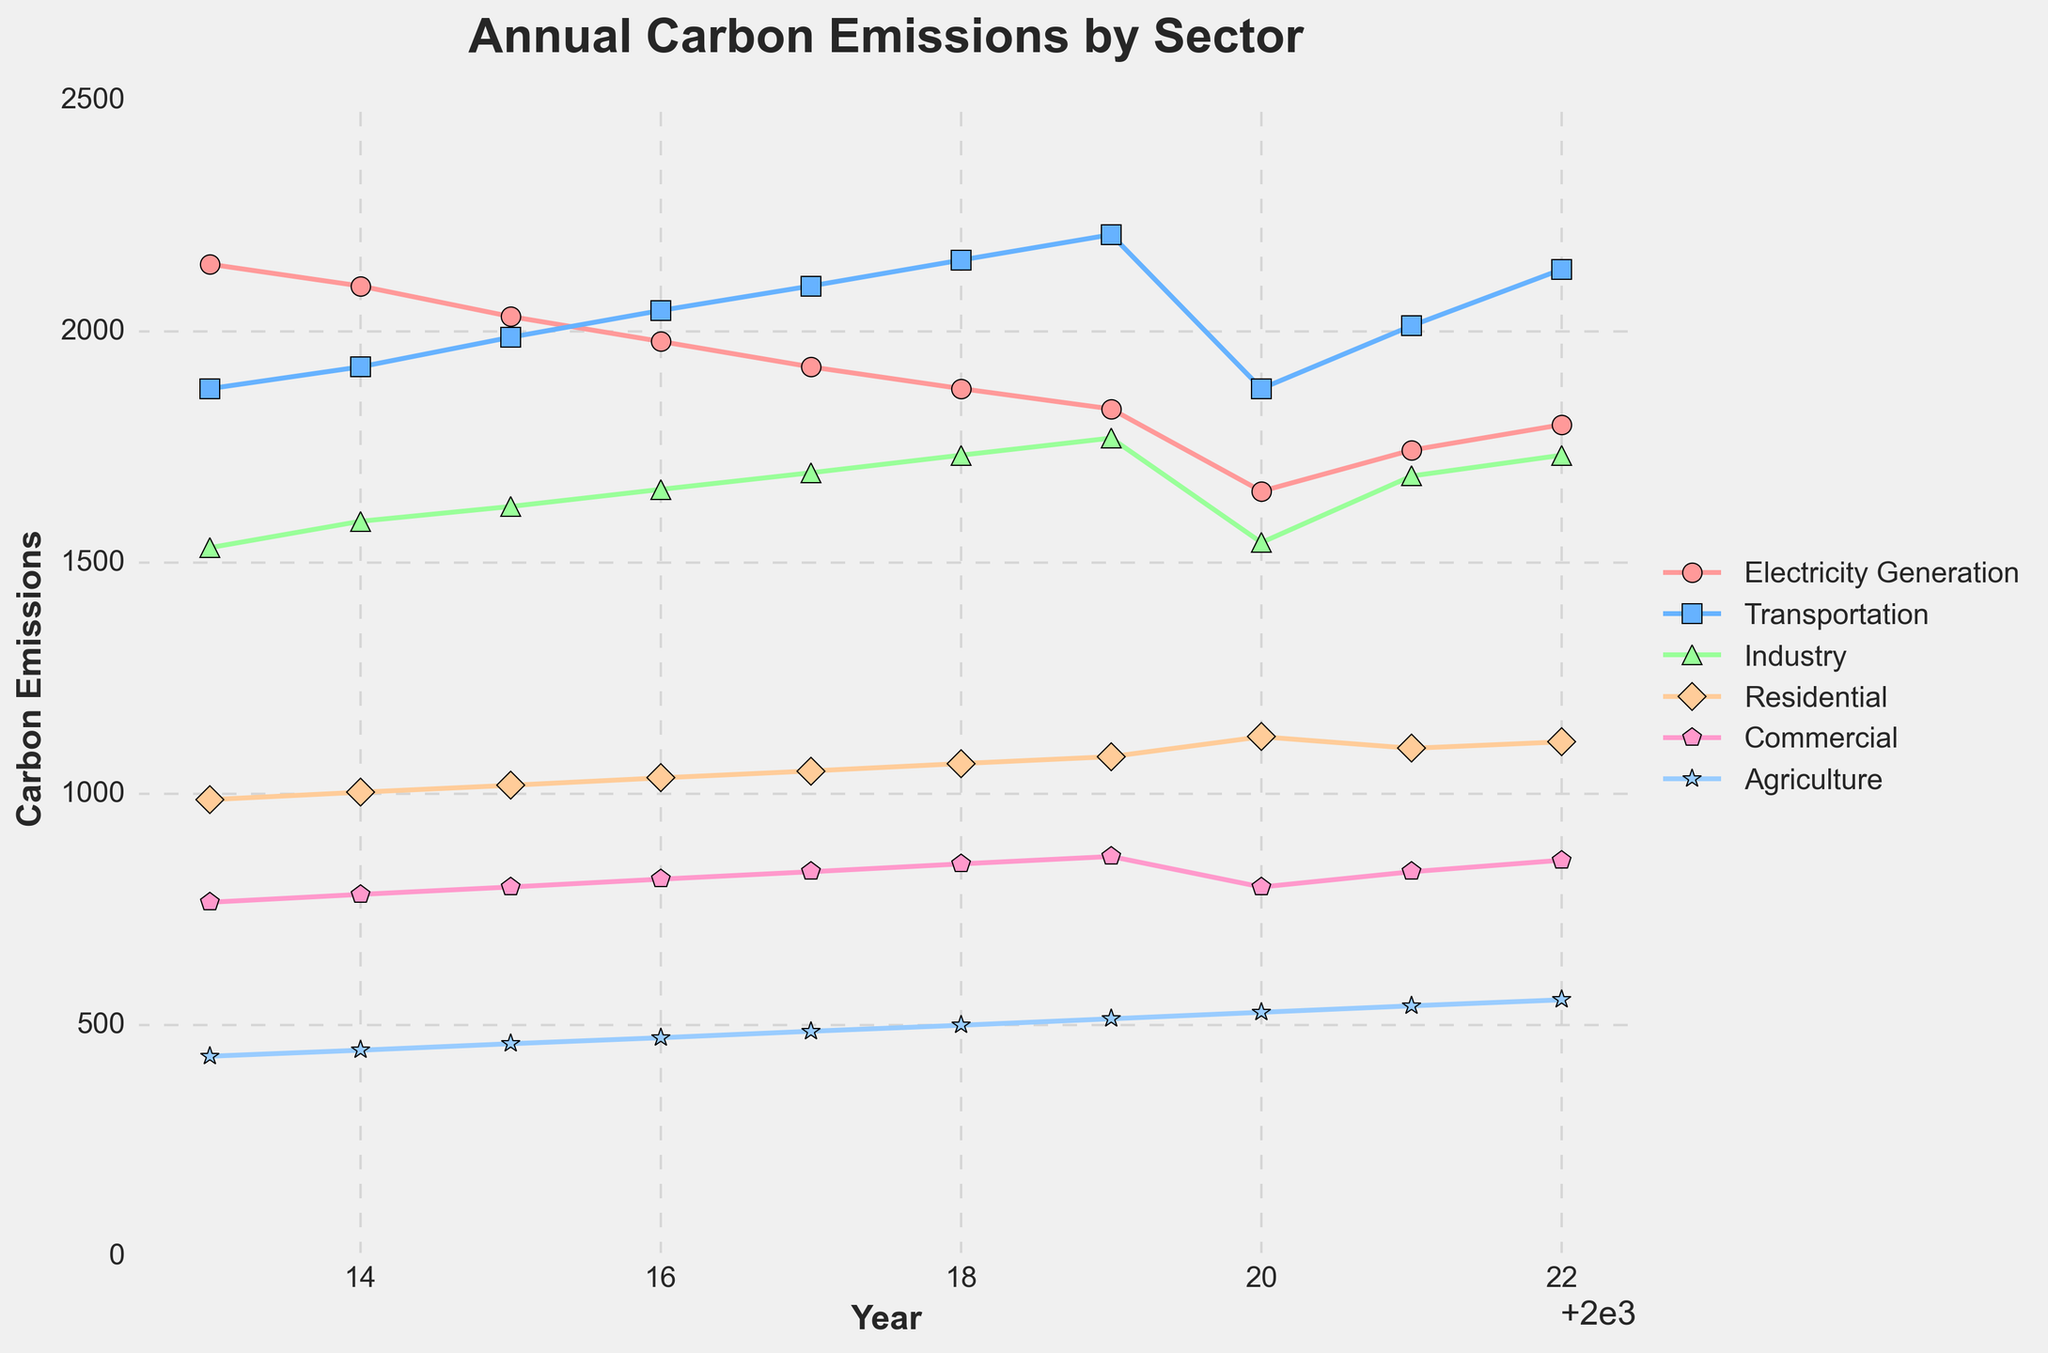What sector had the highest carbon emissions in 2019? To determine the sector with the highest carbon emissions in 2019, we look at the data for each sector in 2019. Transportation recorded 2209, which is higher than the other sectors.
Answer: Transportation How did carbon emissions from Electricity Generation change from 2013 to 2020? To find the change, we subtract the 2020 value for Electricity Generation (1654) from the 2013 value (2145). 2145 - 1654 = 491.
Answer: Decreased by 491 In which year did Residential carbon emissions peak, and what was the value? Observing the Residential emissions across all years, it peaked in 2020 with a value of 1123.
Answer: 2020, 1123 What is the sum of carbon emissions from Industry and Commercial sectors in 2022? Adding the emissions of Industry (1732) and Commercial (856) in 2022, we get 1732 + 856 = 2588.
Answer: 2588 Which sector's carbon emissions show the greatest increase from 2013 to 2022? To find the greatest increase, we calculate the difference between 2022 and 2013 values for each sector and compare them. Transportation shows an increase from 1876 in 2013 to 2134 in 2022, which is the highest increase, 2134 - 1876 = 258.
Answer: Transportation Is there any year when Agricultural carbon emissions surpass Residential emissions? Comparing the Agricultural and Residential emissions for each year, we see that in no year does Agriculture's emissions (highest being 554 in 2022) surpass Residential (lowest being 987 in 2013).
Answer: No What was the average annual carbon emissions of the Commercial sector over the decade? To find the average, we sum Commercial emissions from 2013 to 2022, which is (765 + 782 + 798 + 815 + 831 + 848 + 864 + 798 + 831 + 856) = 8188, and divide by 10, getting 8188 / 10 = 818.8.
Answer: 818.8 Between which two consecutive years did Transportation sector emissions increase the most? To identify the highest increase, we find the differences between consecutive years for Transportation. The biggest increase is between 2018 (2154) and 2019 (2209), which is 2209 - 2154 = 55.
Answer: 2018 and 2019 During which years did the Agriculture sector experience continuous growth in emissions? Checking annual values for continuous growth, we see from 2013 to 2022, the period 2015 to 2022 shows continuous increase from 459 to 554.
Answer: 2015 to 2022 